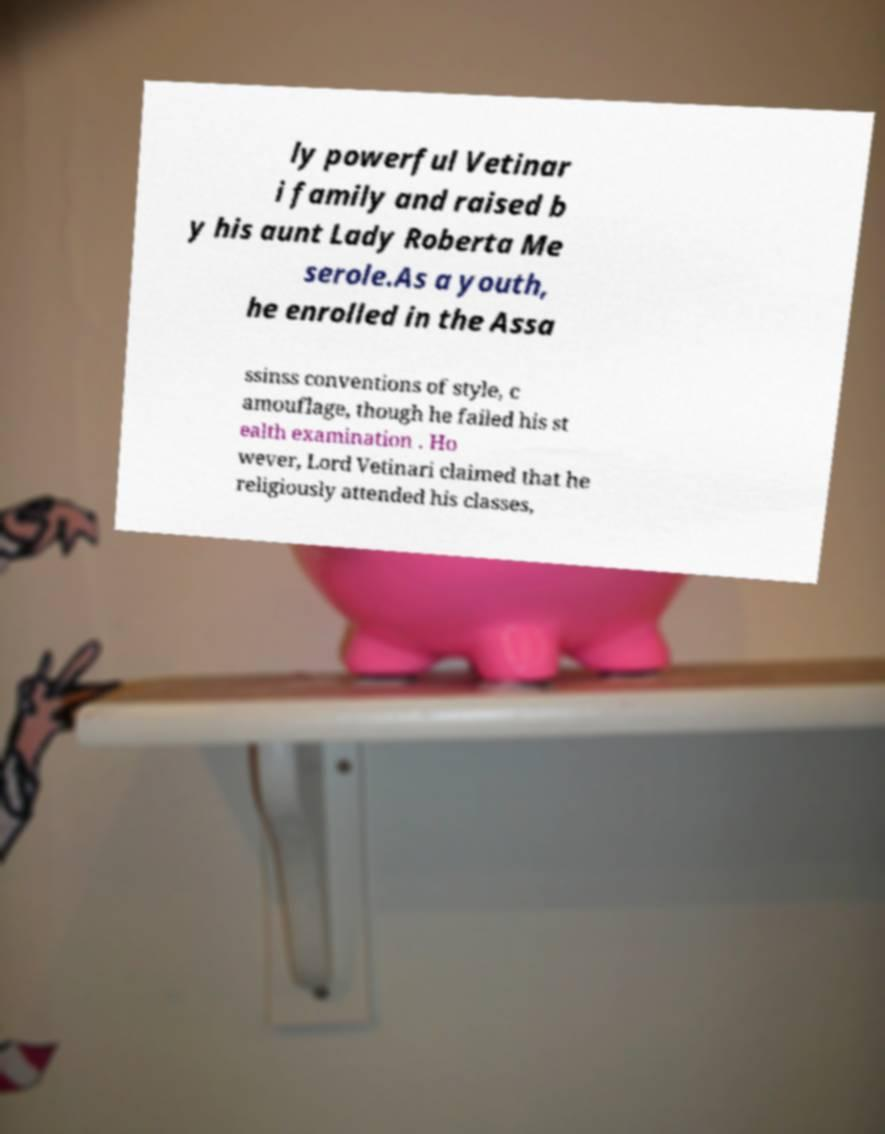Could you assist in decoding the text presented in this image and type it out clearly? ly powerful Vetinar i family and raised b y his aunt Lady Roberta Me serole.As a youth, he enrolled in the Assa ssinss conventions of style, c amouflage, though he failed his st ealth examination . Ho wever, Lord Vetinari claimed that he religiously attended his classes, 